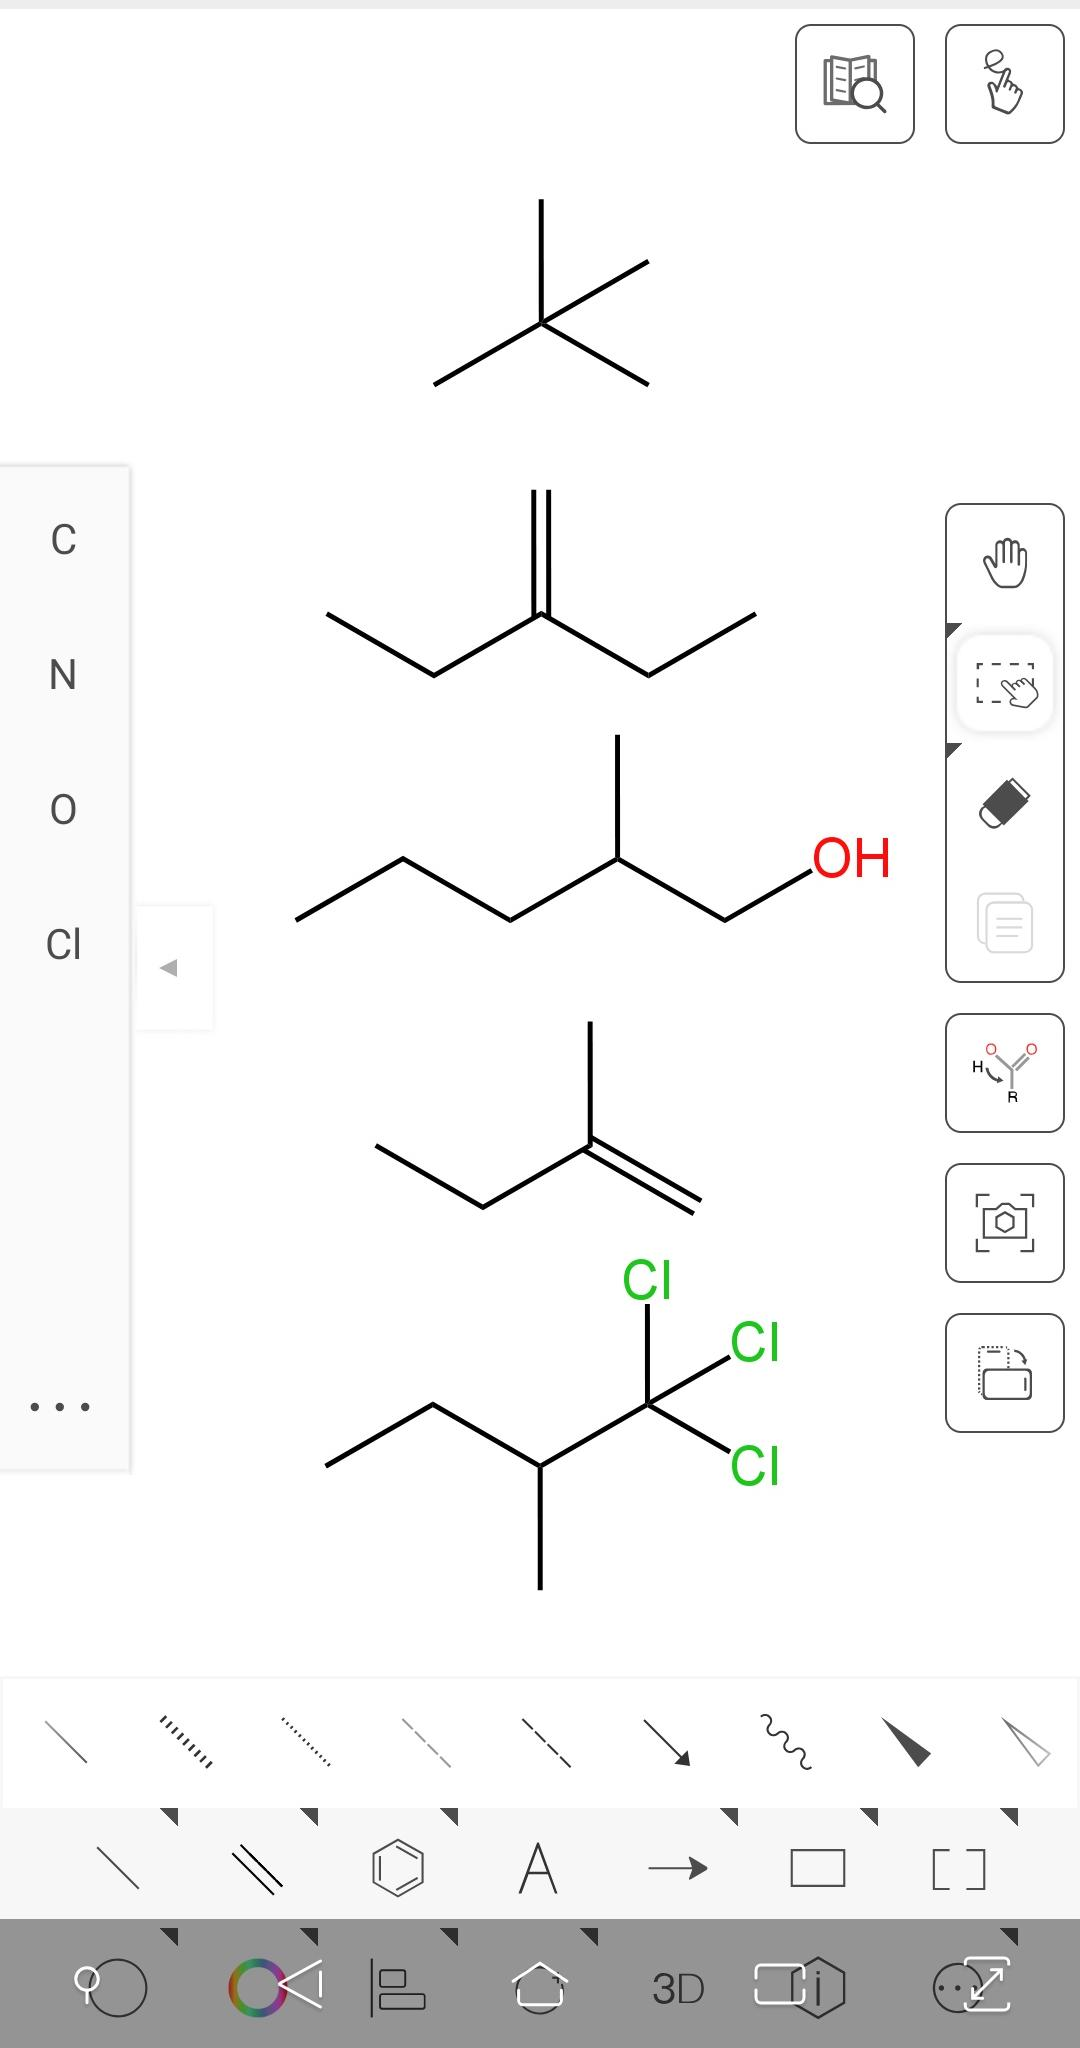Name all 5 chemical compounds one by one The image shows five different organic molecules. From top to bottom, here are their names:

1. The first compound is 2-methylbutane, a branched alkane.

2. The second compound is 3-methylpentane, another branched alkane.

3. The third compound is 2-hexanol, which is an alcohol due to the presence of the hydroxyl group (-OH) on the second carbon atom.

4. The fourth compound is 2-methyl-2-butene, a branched alkene with a double bond between the second and third carbon atoms.

5. The fifth compound is 1,2,2-trichloropropane, a chlorinated alkane with three chlorine atoms attached to the second carbon atom. 